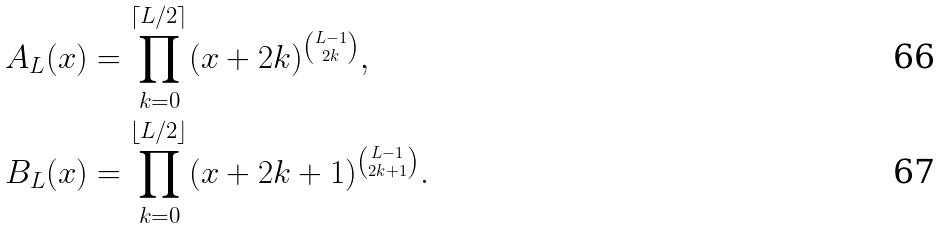Convert formula to latex. <formula><loc_0><loc_0><loc_500><loc_500>A _ { L } ( x ) & = \prod _ { k = 0 } ^ { \lceil L / 2 \rceil } ( x + 2 k ) ^ { \binom { L - 1 } { 2 k } } , \\ B _ { L } ( x ) & = \prod _ { k = 0 } ^ { \lfloor L / 2 \rfloor } ( x + 2 k + 1 ) ^ { \binom { L - 1 } { 2 k + 1 } } .</formula> 